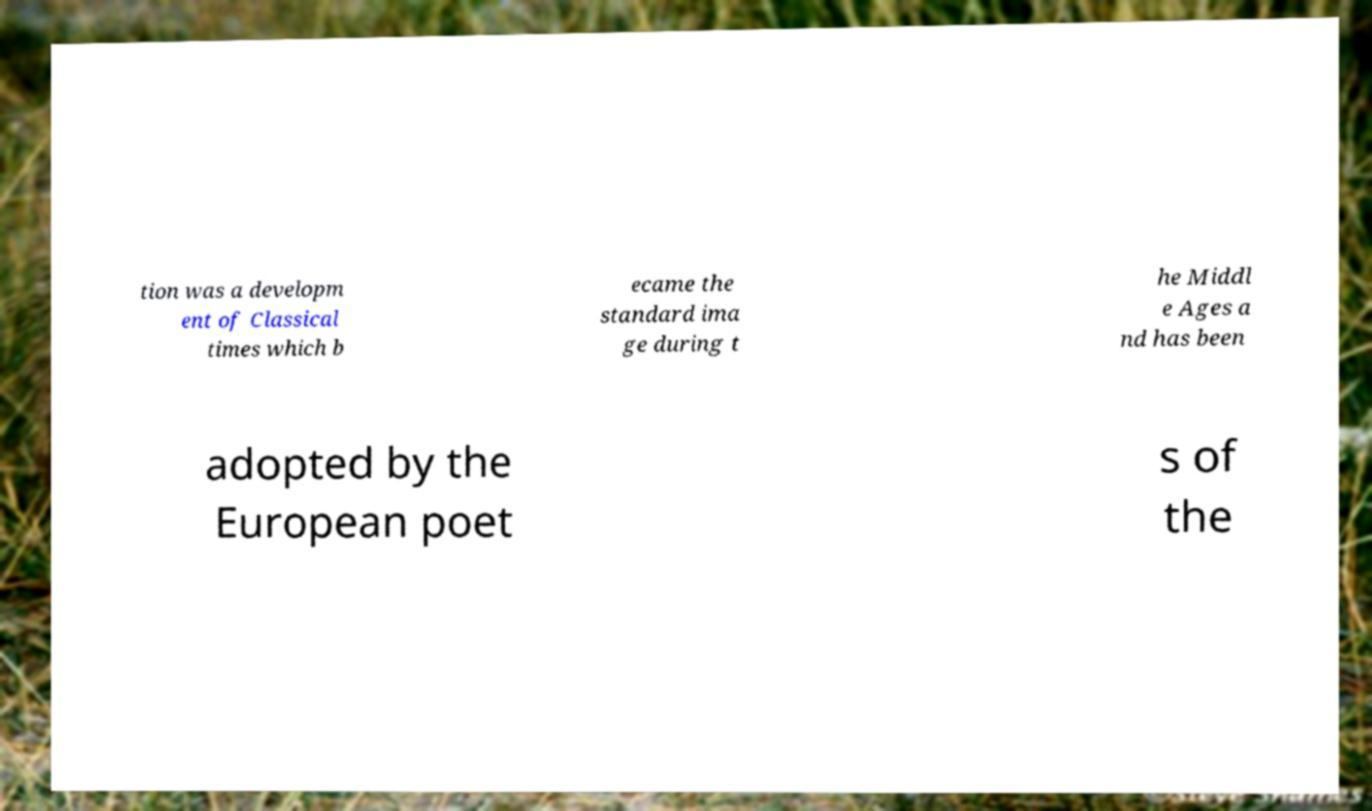Please read and relay the text visible in this image. What does it say? tion was a developm ent of Classical times which b ecame the standard ima ge during t he Middl e Ages a nd has been adopted by the European poet s of the 